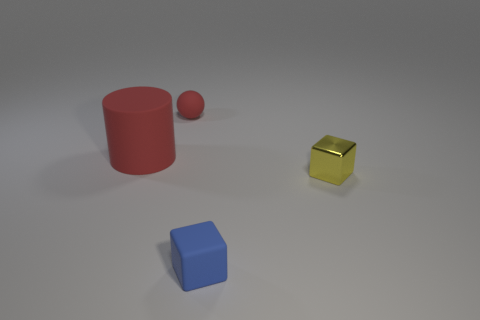Does the object that is to the left of the rubber sphere have the same color as the small rubber object that is behind the red matte cylinder?
Offer a terse response. Yes. How many yellow rubber cubes are there?
Your answer should be compact. 0. Are there any large red cylinders to the left of the big object?
Offer a terse response. No. Does the small thing that is behind the big object have the same material as the blue cube that is to the right of the cylinder?
Ensure brevity in your answer.  Yes. Are there fewer blue matte blocks behind the red rubber cylinder than small red balls?
Your answer should be compact. Yes. There is a rubber thing that is in front of the small yellow thing; what color is it?
Ensure brevity in your answer.  Blue. What material is the object to the right of the cube that is in front of the shiny cube made of?
Offer a terse response. Metal. Are there any red objects of the same size as the blue matte block?
Provide a short and direct response. Yes. What number of things are either small rubber objects in front of the big rubber object or tiny things that are on the right side of the large red matte object?
Ensure brevity in your answer.  3. Do the cube behind the tiny blue rubber object and the rubber object behind the big thing have the same size?
Offer a very short reply. Yes. 